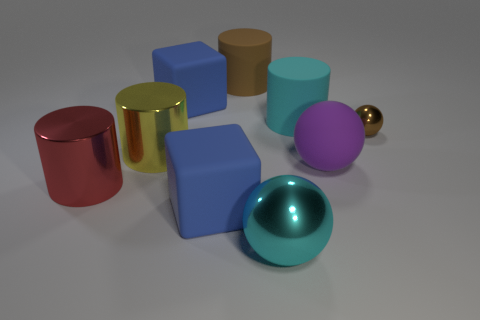What is the material of the cyan thing that is the same shape as the big red metal thing?
Provide a short and direct response. Rubber. What number of things are either big blue objects that are in front of the purple sphere or cylinders that are behind the rubber ball?
Provide a succinct answer. 4. There is a small object; is its color the same as the big cylinder behind the large cyan matte thing?
Keep it short and to the point. Yes. There is a big cyan thing that is made of the same material as the big brown cylinder; what shape is it?
Offer a very short reply. Cylinder. What number of yellow matte objects are there?
Provide a short and direct response. 0. How many objects are cylinders right of the large brown cylinder or green cylinders?
Keep it short and to the point. 1. Is the color of the large shiny cylinder that is in front of the big purple rubber sphere the same as the tiny metal thing?
Provide a short and direct response. No. What number of other things are there of the same color as the tiny metallic thing?
Keep it short and to the point. 1. How many big objects are either cyan rubber cylinders or cylinders?
Offer a very short reply. 4. Are there more brown objects than brown rubber balls?
Keep it short and to the point. Yes. 